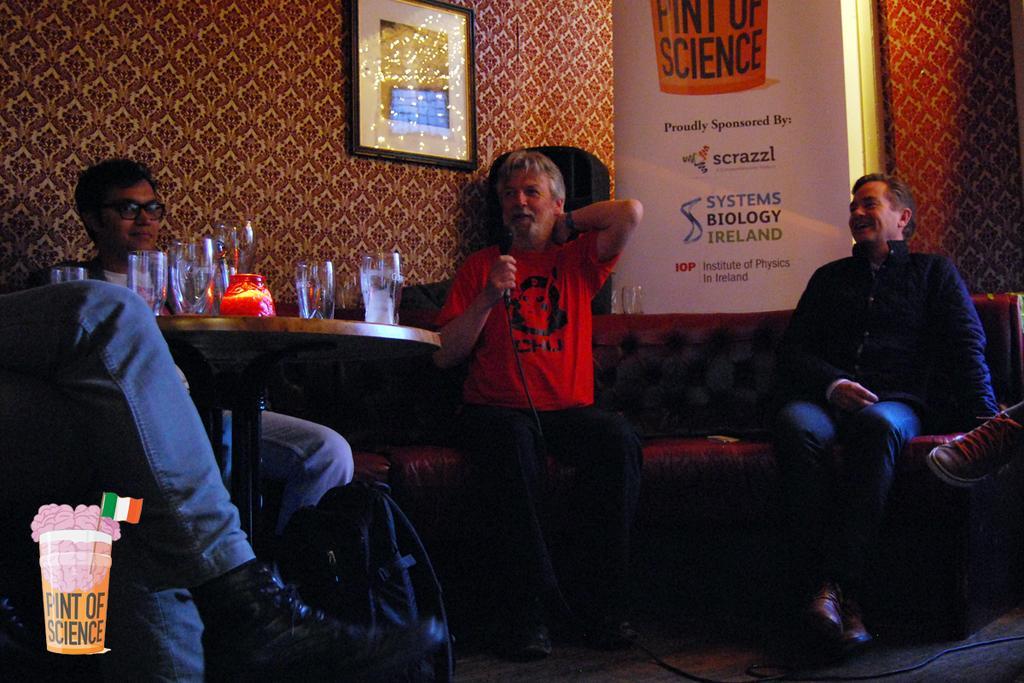How would you summarize this image in a sentence or two? There are three people sitting on the sofas and a table in front of them on which there are some glasses and among them a person is holding a mike. 